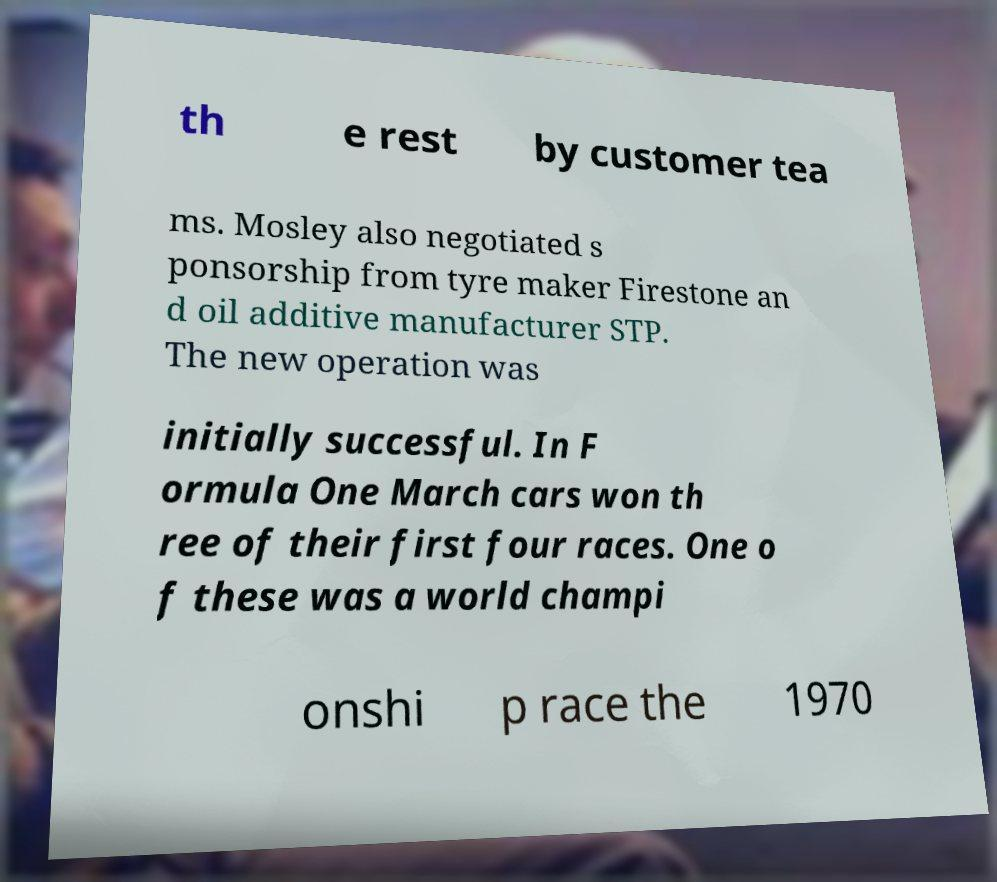Could you assist in decoding the text presented in this image and type it out clearly? th e rest by customer tea ms. Mosley also negotiated s ponsorship from tyre maker Firestone an d oil additive manufacturer STP. The new operation was initially successful. In F ormula One March cars won th ree of their first four races. One o f these was a world champi onshi p race the 1970 